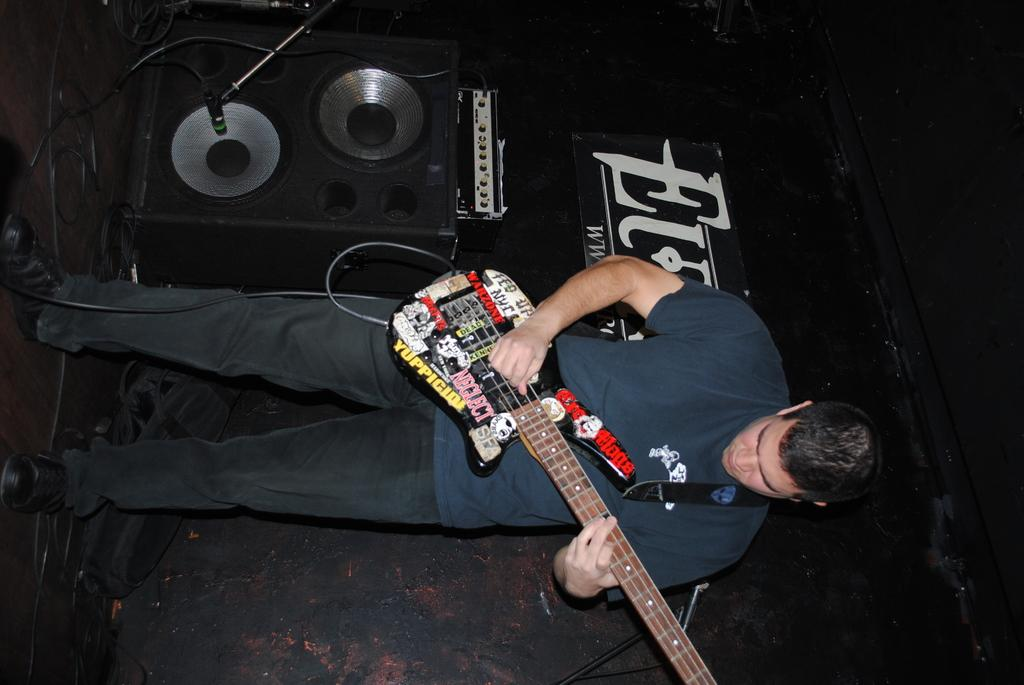What is the person in the image doing? The person is standing in the image and holding a guitar. What object is present in the image that is typically used for amplifying sound? There is a speaker in the image. What object is present in the image that is typically used for vocal amplification? There is a microphone with a stand in the image. Can you tell me how many horses are present in the image? There are no horses present in the image. What fact can be determined about the person's musical abilities from the image? The image does not provide any information about the person's musical abilities. 